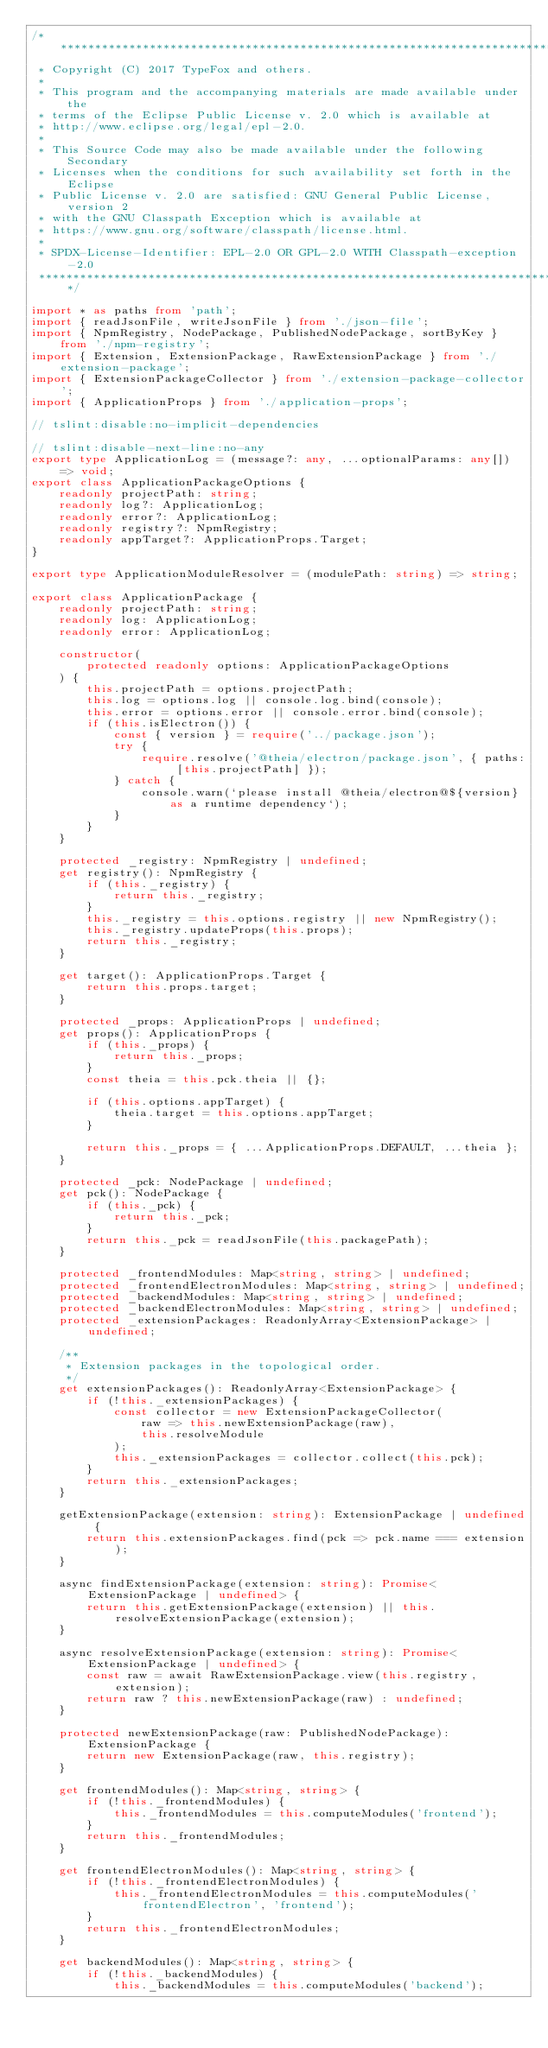Convert code to text. <code><loc_0><loc_0><loc_500><loc_500><_TypeScript_>/********************************************************************************
 * Copyright (C) 2017 TypeFox and others.
 *
 * This program and the accompanying materials are made available under the
 * terms of the Eclipse Public License v. 2.0 which is available at
 * http://www.eclipse.org/legal/epl-2.0.
 *
 * This Source Code may also be made available under the following Secondary
 * Licenses when the conditions for such availability set forth in the Eclipse
 * Public License v. 2.0 are satisfied: GNU General Public License, version 2
 * with the GNU Classpath Exception which is available at
 * https://www.gnu.org/software/classpath/license.html.
 *
 * SPDX-License-Identifier: EPL-2.0 OR GPL-2.0 WITH Classpath-exception-2.0
 ********************************************************************************/

import * as paths from 'path';
import { readJsonFile, writeJsonFile } from './json-file';
import { NpmRegistry, NodePackage, PublishedNodePackage, sortByKey } from './npm-registry';
import { Extension, ExtensionPackage, RawExtensionPackage } from './extension-package';
import { ExtensionPackageCollector } from './extension-package-collector';
import { ApplicationProps } from './application-props';

// tslint:disable:no-implicit-dependencies

// tslint:disable-next-line:no-any
export type ApplicationLog = (message?: any, ...optionalParams: any[]) => void;
export class ApplicationPackageOptions {
    readonly projectPath: string;
    readonly log?: ApplicationLog;
    readonly error?: ApplicationLog;
    readonly registry?: NpmRegistry;
    readonly appTarget?: ApplicationProps.Target;
}

export type ApplicationModuleResolver = (modulePath: string) => string;

export class ApplicationPackage {
    readonly projectPath: string;
    readonly log: ApplicationLog;
    readonly error: ApplicationLog;

    constructor(
        protected readonly options: ApplicationPackageOptions
    ) {
        this.projectPath = options.projectPath;
        this.log = options.log || console.log.bind(console);
        this.error = options.error || console.error.bind(console);
        if (this.isElectron()) {
            const { version } = require('../package.json');
            try {
                require.resolve('@theia/electron/package.json', { paths: [this.projectPath] });
            } catch {
                console.warn(`please install @theia/electron@${version} as a runtime dependency`);
            }
        }
    }

    protected _registry: NpmRegistry | undefined;
    get registry(): NpmRegistry {
        if (this._registry) {
            return this._registry;
        }
        this._registry = this.options.registry || new NpmRegistry();
        this._registry.updateProps(this.props);
        return this._registry;
    }

    get target(): ApplicationProps.Target {
        return this.props.target;
    }

    protected _props: ApplicationProps | undefined;
    get props(): ApplicationProps {
        if (this._props) {
            return this._props;
        }
        const theia = this.pck.theia || {};

        if (this.options.appTarget) {
            theia.target = this.options.appTarget;
        }

        return this._props = { ...ApplicationProps.DEFAULT, ...theia };
    }

    protected _pck: NodePackage | undefined;
    get pck(): NodePackage {
        if (this._pck) {
            return this._pck;
        }
        return this._pck = readJsonFile(this.packagePath);
    }

    protected _frontendModules: Map<string, string> | undefined;
    protected _frontendElectronModules: Map<string, string> | undefined;
    protected _backendModules: Map<string, string> | undefined;
    protected _backendElectronModules: Map<string, string> | undefined;
    protected _extensionPackages: ReadonlyArray<ExtensionPackage> | undefined;

    /**
     * Extension packages in the topological order.
     */
    get extensionPackages(): ReadonlyArray<ExtensionPackage> {
        if (!this._extensionPackages) {
            const collector = new ExtensionPackageCollector(
                raw => this.newExtensionPackage(raw),
                this.resolveModule
            );
            this._extensionPackages = collector.collect(this.pck);
        }
        return this._extensionPackages;
    }

    getExtensionPackage(extension: string): ExtensionPackage | undefined {
        return this.extensionPackages.find(pck => pck.name === extension);
    }

    async findExtensionPackage(extension: string): Promise<ExtensionPackage | undefined> {
        return this.getExtensionPackage(extension) || this.resolveExtensionPackage(extension);
    }

    async resolveExtensionPackage(extension: string): Promise<ExtensionPackage | undefined> {
        const raw = await RawExtensionPackage.view(this.registry, extension);
        return raw ? this.newExtensionPackage(raw) : undefined;
    }

    protected newExtensionPackage(raw: PublishedNodePackage): ExtensionPackage {
        return new ExtensionPackage(raw, this.registry);
    }

    get frontendModules(): Map<string, string> {
        if (!this._frontendModules) {
            this._frontendModules = this.computeModules('frontend');
        }
        return this._frontendModules;
    }

    get frontendElectronModules(): Map<string, string> {
        if (!this._frontendElectronModules) {
            this._frontendElectronModules = this.computeModules('frontendElectron', 'frontend');
        }
        return this._frontendElectronModules;
    }

    get backendModules(): Map<string, string> {
        if (!this._backendModules) {
            this._backendModules = this.computeModules('backend');</code> 